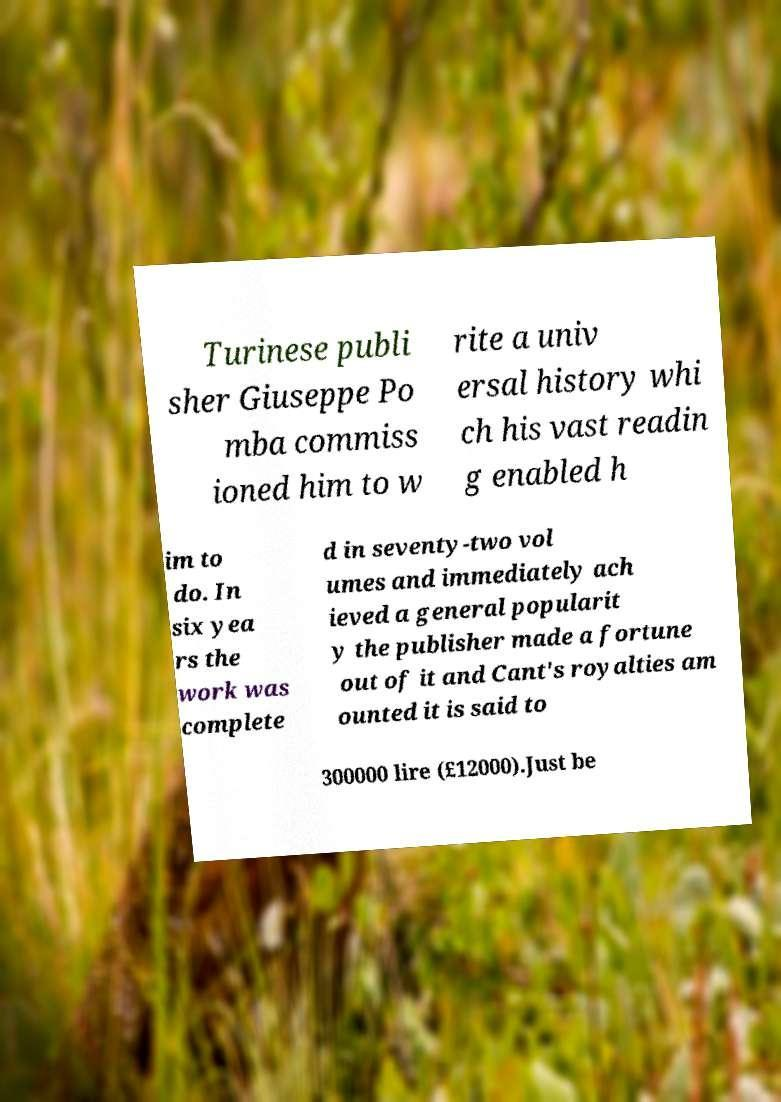What messages or text are displayed in this image? I need them in a readable, typed format. Turinese publi sher Giuseppe Po mba commiss ioned him to w rite a univ ersal history whi ch his vast readin g enabled h im to do. In six yea rs the work was complete d in seventy-two vol umes and immediately ach ieved a general popularit y the publisher made a fortune out of it and Cant's royalties am ounted it is said to 300000 lire (£12000).Just be 